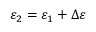<formula> <loc_0><loc_0><loc_500><loc_500>\varepsilon _ { 2 } = \varepsilon _ { 1 } + \Delta \varepsilon</formula> 